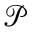Convert formula to latex. <formula><loc_0><loc_0><loc_500><loc_500>\mathcal { P }</formula> 